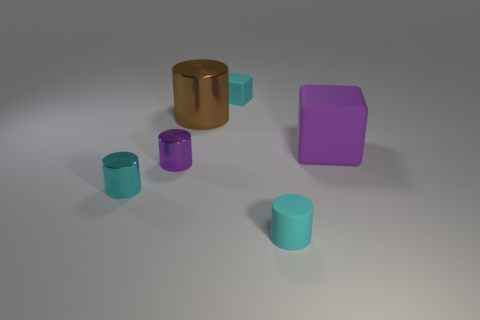How big is the brown thing?
Your response must be concise. Large. How many other objects are the same color as the small matte cylinder?
Your answer should be very brief. 2. Do the small thing that is behind the large brown metallic cylinder and the tiny purple object have the same material?
Make the answer very short. No. Is the number of large shiny objects that are in front of the brown cylinder less than the number of shiny cylinders that are in front of the small purple shiny object?
Offer a very short reply. Yes. How many other things are there of the same material as the cyan cube?
Your answer should be very brief. 2. There is a purple thing that is the same size as the cyan metal thing; what is it made of?
Provide a succinct answer. Metal. Is the number of big matte things to the left of the big purple matte object less than the number of small blue matte spheres?
Provide a succinct answer. No. What shape is the small cyan rubber thing in front of the metallic cylinder that is behind the large object that is right of the cyan matte cube?
Your response must be concise. Cylinder. There is a rubber block that is to the right of the small rubber cube; what is its size?
Your answer should be very brief. Large. There is a purple thing that is the same size as the brown metal object; what shape is it?
Provide a succinct answer. Cube. 